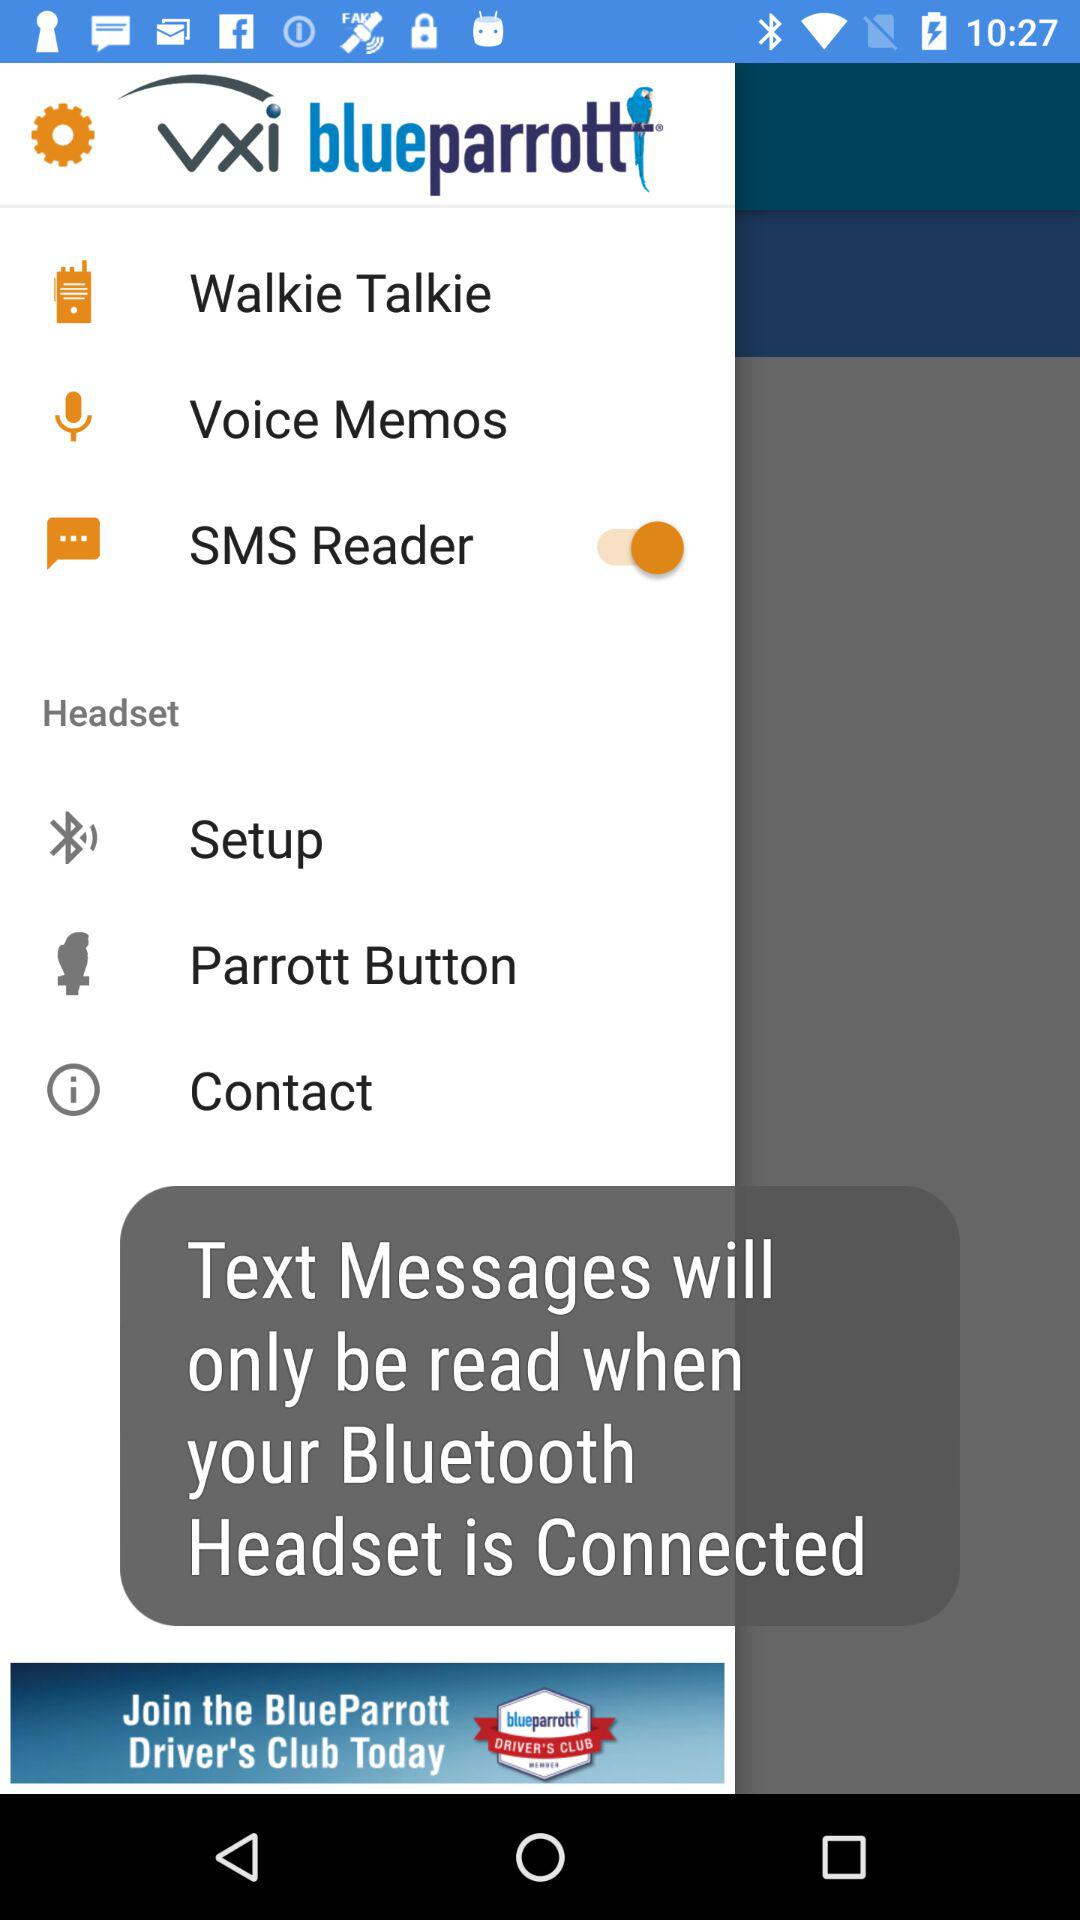What is the status of "SMS Reader"? The status is "on". 